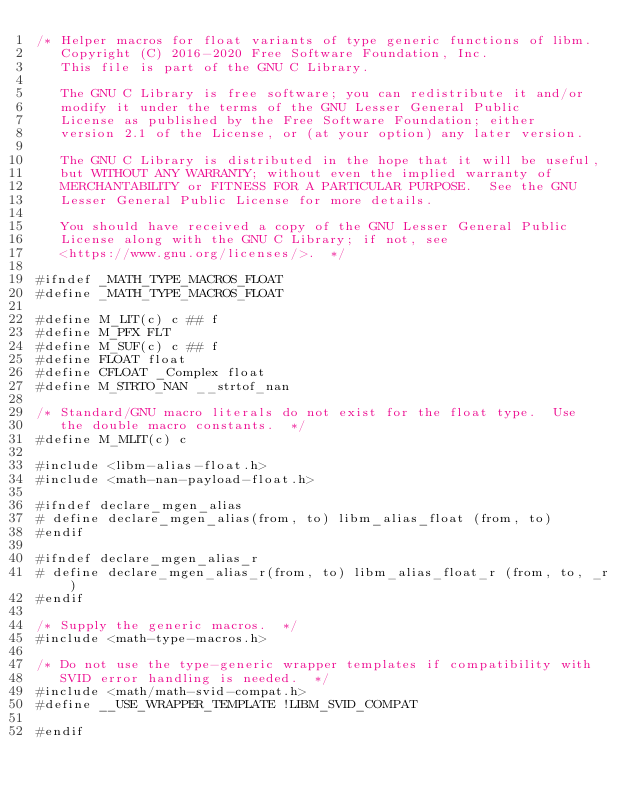Convert code to text. <code><loc_0><loc_0><loc_500><loc_500><_C_>/* Helper macros for float variants of type generic functions of libm.
   Copyright (C) 2016-2020 Free Software Foundation, Inc.
   This file is part of the GNU C Library.

   The GNU C Library is free software; you can redistribute it and/or
   modify it under the terms of the GNU Lesser General Public
   License as published by the Free Software Foundation; either
   version 2.1 of the License, or (at your option) any later version.

   The GNU C Library is distributed in the hope that it will be useful,
   but WITHOUT ANY WARRANTY; without even the implied warranty of
   MERCHANTABILITY or FITNESS FOR A PARTICULAR PURPOSE.  See the GNU
   Lesser General Public License for more details.

   You should have received a copy of the GNU Lesser General Public
   License along with the GNU C Library; if not, see
   <https://www.gnu.org/licenses/>.  */

#ifndef _MATH_TYPE_MACROS_FLOAT
#define _MATH_TYPE_MACROS_FLOAT

#define M_LIT(c) c ## f
#define M_PFX FLT
#define M_SUF(c) c ## f
#define FLOAT float
#define CFLOAT _Complex float
#define M_STRTO_NAN __strtof_nan

/* Standard/GNU macro literals do not exist for the float type.  Use
   the double macro constants.  */
#define M_MLIT(c) c

#include <libm-alias-float.h>
#include <math-nan-payload-float.h>

#ifndef declare_mgen_alias
# define declare_mgen_alias(from, to) libm_alias_float (from, to)
#endif

#ifndef declare_mgen_alias_r
# define declare_mgen_alias_r(from, to) libm_alias_float_r (from, to, _r)
#endif

/* Supply the generic macros.  */
#include <math-type-macros.h>

/* Do not use the type-generic wrapper templates if compatibility with
   SVID error handling is needed.  */
#include <math/math-svid-compat.h>
#define __USE_WRAPPER_TEMPLATE !LIBM_SVID_COMPAT

#endif
</code> 